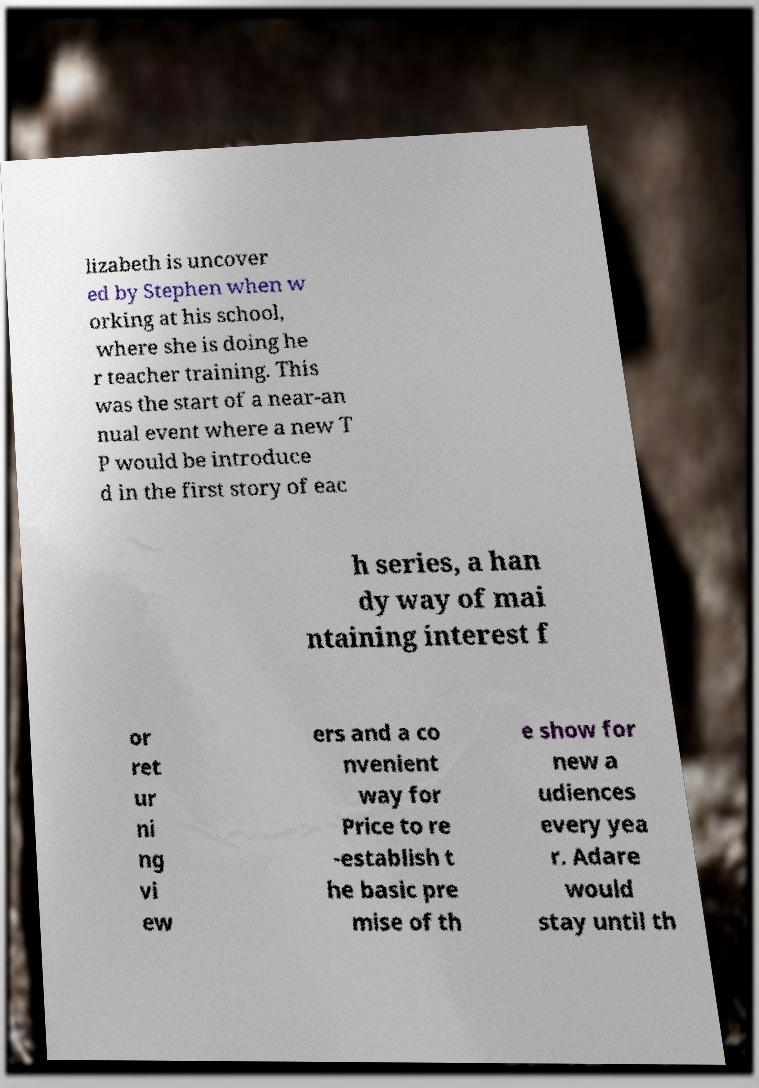Could you assist in decoding the text presented in this image and type it out clearly? lizabeth is uncover ed by Stephen when w orking at his school, where she is doing he r teacher training. This was the start of a near-an nual event where a new T P would be introduce d in the first story of eac h series, a han dy way of mai ntaining interest f or ret ur ni ng vi ew ers and a co nvenient way for Price to re -establish t he basic pre mise of th e show for new a udiences every yea r. Adare would stay until th 